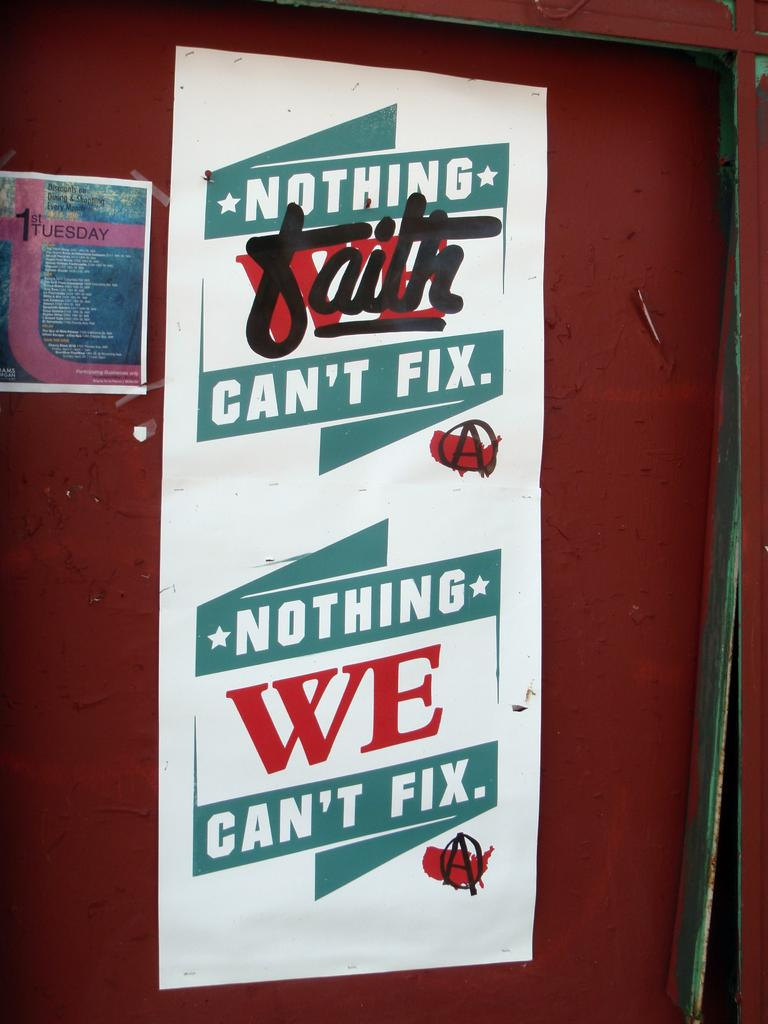<image>
Write a terse but informative summary of the picture. A nothing faith can't fix poster sits against a red wall 